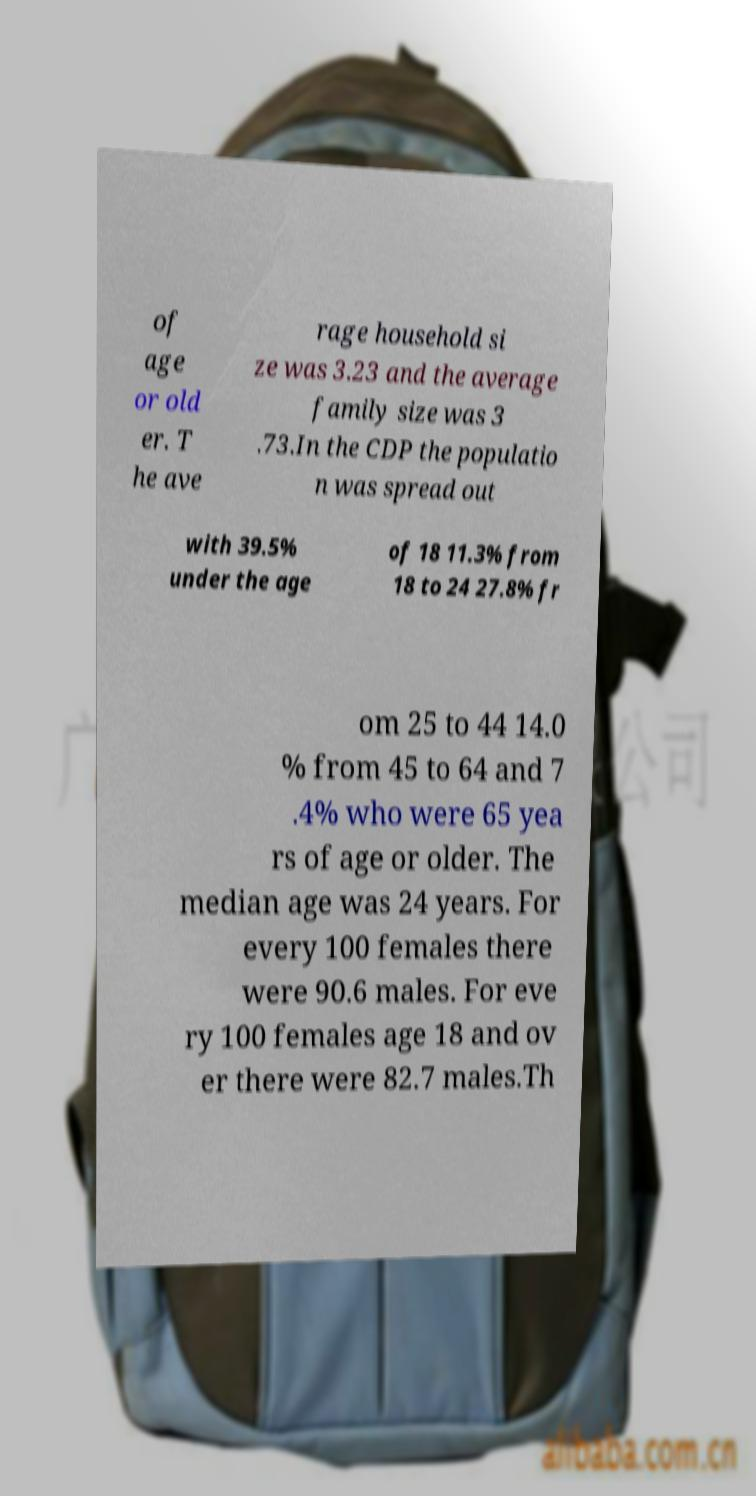There's text embedded in this image that I need extracted. Can you transcribe it verbatim? of age or old er. T he ave rage household si ze was 3.23 and the average family size was 3 .73.In the CDP the populatio n was spread out with 39.5% under the age of 18 11.3% from 18 to 24 27.8% fr om 25 to 44 14.0 % from 45 to 64 and 7 .4% who were 65 yea rs of age or older. The median age was 24 years. For every 100 females there were 90.6 males. For eve ry 100 females age 18 and ov er there were 82.7 males.Th 